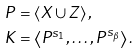<formula> <loc_0><loc_0><loc_500><loc_500>P & = \left \langle X \cup Z \right \rangle , \\ K & = \left \langle P ^ { s _ { 1 } } , \dots , P ^ { s _ { \beta } } \right \rangle .</formula> 